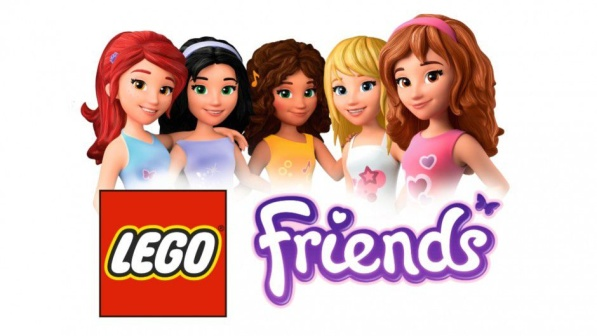Explain the visual content of the image in great detail. The image presents a lively scene featuring five Lego Friends characters, all of whom are girls. They are standing shoulder to shoulder, forming a line that spans the width of the image. Each character is unique, distinguished by their individual outfits and hairstyles. 

On the far left, the first girl is wearing a purple top and blue skirt, her brown hair styled in a ponytail. Next to her, the second girl is dressed in a pink top and blue shorts, her blonde hair cascading down her shoulders. The middle character, the third girl, sports a red top and blue skirt, her black hair styled in a bob. The fourth girl, standing to the right of the center, is wearing a green top and blue skirt, her brown hair styled in a bun. Finally, on the far right, the fifth girl is dressed in a blue top and pink skirt, her blonde hair styled in a ponytail.

Each character is uniquely posed, adding a dynamic element to the scene. Their outfits and hairstyles are not only different in color but also in design, showcasing the diversity of the Lego Friends line.

In the bottom left corner of the image, the Lego Friends logo is prominently displayed. The word "Lego" is written in bold red letters, while "Friends" is in vibrant yellow. The logo stands out against the white background of the image, drawing attention to the brand and the theme of friendship it represents. 

The entire scene is set against a stark white background, which serves to highlight the colorful characters and logo. The image does not contain any text other than the Lego Friends logo. The relative positions of the characters and the logo remain constant, with the characters always appearing above the logo. The image is a celebration of friendship, diversity, and creativity, encapsulating the spirit of the Lego Friends line. 